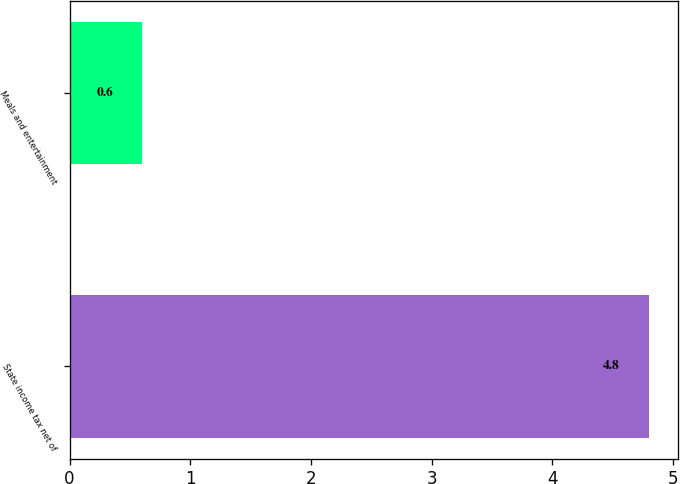Convert chart to OTSL. <chart><loc_0><loc_0><loc_500><loc_500><bar_chart><fcel>State income tax net of<fcel>Meals and entertainment<nl><fcel>4.8<fcel>0.6<nl></chart> 